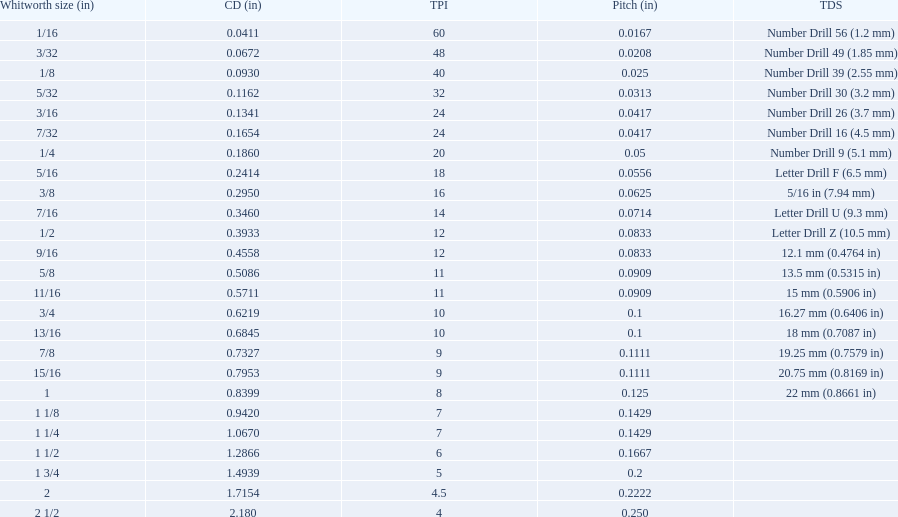What is the total of the first two core diameters? 0.1083. Parse the table in full. {'header': ['Whitworth size (in)', 'CD (in)', 'TPI', 'Pitch (in)', 'TDS'], 'rows': [['1/16', '0.0411', '60', '0.0167', 'Number Drill 56 (1.2\xa0mm)'], ['3/32', '0.0672', '48', '0.0208', 'Number Drill 49 (1.85\xa0mm)'], ['1/8', '0.0930', '40', '0.025', 'Number Drill 39 (2.55\xa0mm)'], ['5/32', '0.1162', '32', '0.0313', 'Number Drill 30 (3.2\xa0mm)'], ['3/16', '0.1341', '24', '0.0417', 'Number Drill 26 (3.7\xa0mm)'], ['7/32', '0.1654', '24', '0.0417', 'Number Drill 16 (4.5\xa0mm)'], ['1/4', '0.1860', '20', '0.05', 'Number Drill 9 (5.1\xa0mm)'], ['5/16', '0.2414', '18', '0.0556', 'Letter Drill F (6.5\xa0mm)'], ['3/8', '0.2950', '16', '0.0625', '5/16\xa0in (7.94\xa0mm)'], ['7/16', '0.3460', '14', '0.0714', 'Letter Drill U (9.3\xa0mm)'], ['1/2', '0.3933', '12', '0.0833', 'Letter Drill Z (10.5\xa0mm)'], ['9/16', '0.4558', '12', '0.0833', '12.1\xa0mm (0.4764\xa0in)'], ['5/8', '0.5086', '11', '0.0909', '13.5\xa0mm (0.5315\xa0in)'], ['11/16', '0.5711', '11', '0.0909', '15\xa0mm (0.5906\xa0in)'], ['3/4', '0.6219', '10', '0.1', '16.27\xa0mm (0.6406\xa0in)'], ['13/16', '0.6845', '10', '0.1', '18\xa0mm (0.7087\xa0in)'], ['7/8', '0.7327', '9', '0.1111', '19.25\xa0mm (0.7579\xa0in)'], ['15/16', '0.7953', '9', '0.1111', '20.75\xa0mm (0.8169\xa0in)'], ['1', '0.8399', '8', '0.125', '22\xa0mm (0.8661\xa0in)'], ['1 1/8', '0.9420', '7', '0.1429', ''], ['1 1/4', '1.0670', '7', '0.1429', ''], ['1 1/2', '1.2866', '6', '0.1667', ''], ['1 3/4', '1.4939', '5', '0.2', ''], ['2', '1.7154', '4.5', '0.2222', ''], ['2 1/2', '2.180', '4', '0.250', '']]} 